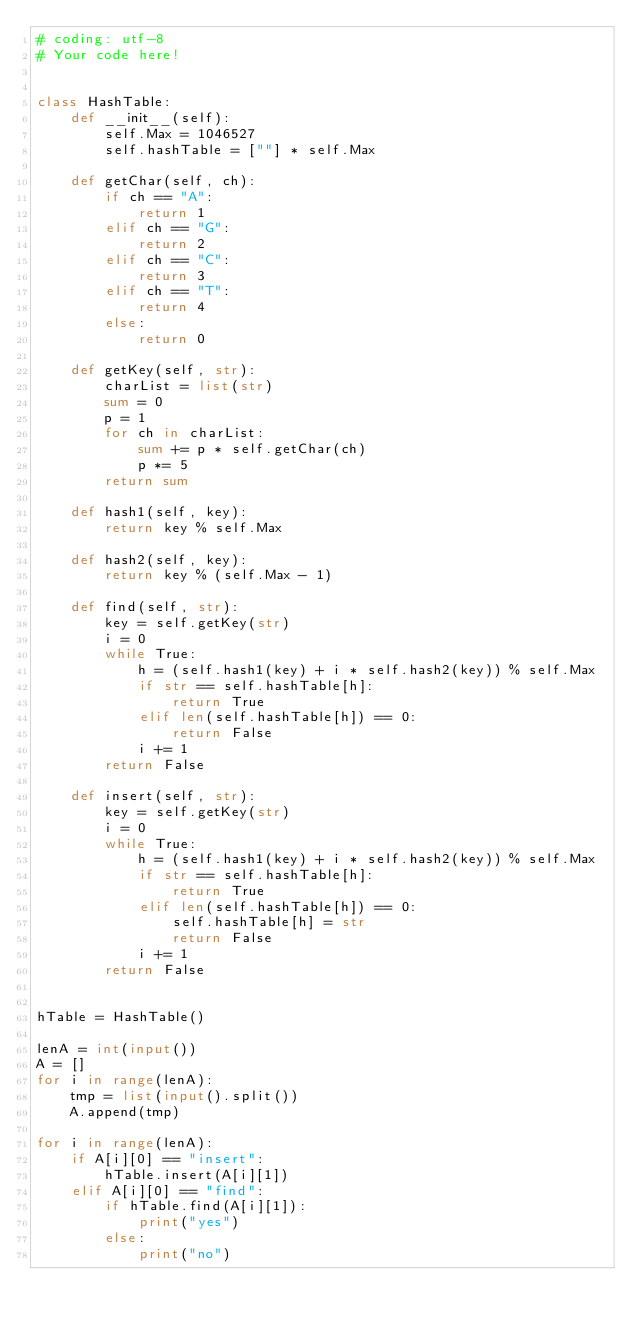<code> <loc_0><loc_0><loc_500><loc_500><_Python_># coding: utf-8
# Your code here!


class HashTable:
    def __init__(self):
        self.Max = 1046527
        self.hashTable = [""] * self.Max
        
    def getChar(self, ch):
        if ch == "A":
            return 1
        elif ch == "G":
            return 2
        elif ch == "C":
            return 3
        elif ch == "T":
            return 4
        else:
            return 0
    
    def getKey(self, str):
        charList = list(str)
        sum = 0
        p = 1
        for ch in charList:
            sum += p * self.getChar(ch)
            p *= 5
        return sum

    def hash1(self, key):
        return key % self.Max
        
    def hash2(self, key):
        return key % (self.Max - 1)

    def find(self, str):
        key = self.getKey(str)
        i = 0
        while True:
            h = (self.hash1(key) + i * self.hash2(key)) % self.Max
            if str == self.hashTable[h]:
                return True
            elif len(self.hashTable[h]) == 0:
                return False
            i += 1
        return False

    def insert(self, str):
        key = self.getKey(str)
        i = 0
        while True:
            h = (self.hash1(key) + i * self.hash2(key)) % self.Max
            if str == self.hashTable[h]:
                return True
            elif len(self.hashTable[h]) == 0:
                self.hashTable[h] = str
                return False
            i += 1
        return False
        

hTable = HashTable()

lenA = int(input())
A = []
for i in range(lenA):
    tmp = list(input().split())
    A.append(tmp)

for i in range(lenA):
    if A[i][0] == "insert":
        hTable.insert(A[i][1])
    elif A[i][0] == "find":
        if hTable.find(A[i][1]):
            print("yes")
        else:
            print("no")
    
    















</code> 